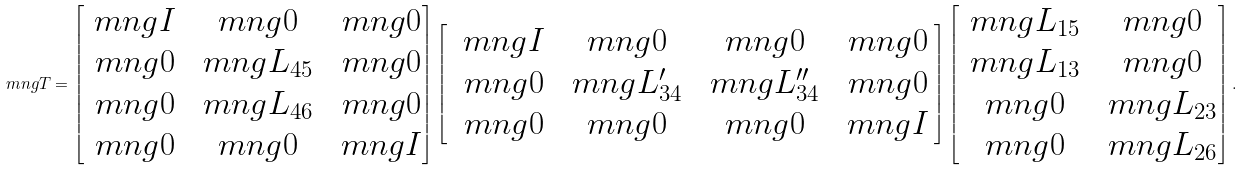Convert formula to latex. <formula><loc_0><loc_0><loc_500><loc_500>\ m n g { T } = \begin{bmatrix} \ m n g { I } & \ m n g { 0 } & \ m n g { 0 } \\ \ m n g { 0 } & \ m n g { L } _ { 4 5 } & \ m n g { 0 } \\ \ m n g { 0 } & \ m n g { L } _ { 4 6 } & \ m n g { 0 } \\ \ m n g { 0 } & \ m n g { 0 } & \ m n g { I } \end{bmatrix} \begin{bmatrix} \, \ m n g { I } & \ m n g { 0 } & \ m n g { 0 } & \ m n g { 0 } \, \\ \, \ m n g { 0 } & \ m n g { L } _ { 3 4 } ^ { \prime } & \ m n g { L } _ { 3 4 } ^ { \prime \prime } & \ m n g { 0 } \, \\ \, \ m n g { 0 } & \ m n g { 0 } & \ m n g { 0 } & \ m n g { I } \, \end{bmatrix} \begin{bmatrix} \ m n g { L } _ { 1 5 } & \ m n g { 0 } \\ \ m n g { L } _ { 1 3 } & \ m n g { 0 } \\ \ m n g { 0 } & \ m n g { L } _ { 2 3 } \\ \ m n g { 0 } & \ m n g { L } _ { 2 6 } \end{bmatrix} .</formula> 